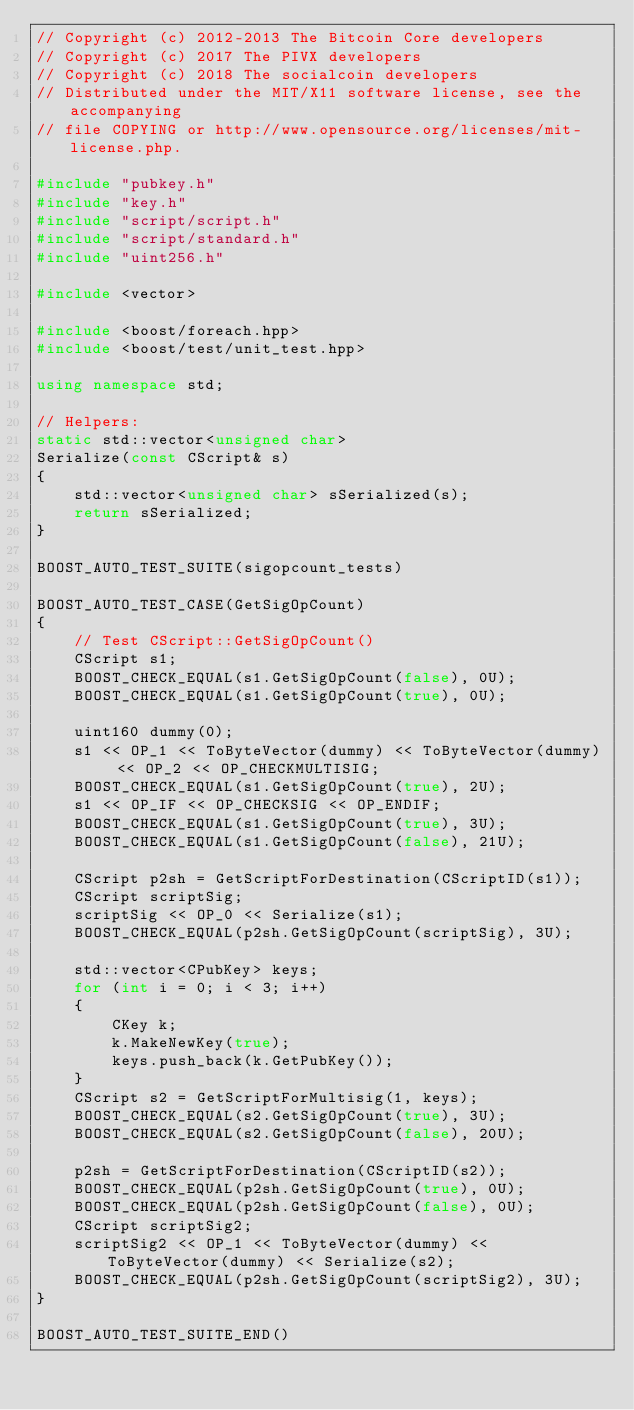Convert code to text. <code><loc_0><loc_0><loc_500><loc_500><_C++_>// Copyright (c) 2012-2013 The Bitcoin Core developers
// Copyright (c) 2017 The PIVX developers
// Copyright (c) 2018 The socialcoin developers
// Distributed under the MIT/X11 software license, see the accompanying
// file COPYING or http://www.opensource.org/licenses/mit-license.php.

#include "pubkey.h"
#include "key.h"
#include "script/script.h"
#include "script/standard.h"
#include "uint256.h"

#include <vector>

#include <boost/foreach.hpp>
#include <boost/test/unit_test.hpp>

using namespace std;

// Helpers:
static std::vector<unsigned char>
Serialize(const CScript& s)
{
    std::vector<unsigned char> sSerialized(s);
    return sSerialized;
}

BOOST_AUTO_TEST_SUITE(sigopcount_tests)

BOOST_AUTO_TEST_CASE(GetSigOpCount)
{
    // Test CScript::GetSigOpCount()
    CScript s1;
    BOOST_CHECK_EQUAL(s1.GetSigOpCount(false), 0U);
    BOOST_CHECK_EQUAL(s1.GetSigOpCount(true), 0U);

    uint160 dummy(0);
    s1 << OP_1 << ToByteVector(dummy) << ToByteVector(dummy) << OP_2 << OP_CHECKMULTISIG;
    BOOST_CHECK_EQUAL(s1.GetSigOpCount(true), 2U);
    s1 << OP_IF << OP_CHECKSIG << OP_ENDIF;
    BOOST_CHECK_EQUAL(s1.GetSigOpCount(true), 3U);
    BOOST_CHECK_EQUAL(s1.GetSigOpCount(false), 21U);

    CScript p2sh = GetScriptForDestination(CScriptID(s1));
    CScript scriptSig;
    scriptSig << OP_0 << Serialize(s1);
    BOOST_CHECK_EQUAL(p2sh.GetSigOpCount(scriptSig), 3U);

    std::vector<CPubKey> keys;
    for (int i = 0; i < 3; i++)
    {
        CKey k;
        k.MakeNewKey(true);
        keys.push_back(k.GetPubKey());
    }
    CScript s2 = GetScriptForMultisig(1, keys);
    BOOST_CHECK_EQUAL(s2.GetSigOpCount(true), 3U);
    BOOST_CHECK_EQUAL(s2.GetSigOpCount(false), 20U);

    p2sh = GetScriptForDestination(CScriptID(s2));
    BOOST_CHECK_EQUAL(p2sh.GetSigOpCount(true), 0U);
    BOOST_CHECK_EQUAL(p2sh.GetSigOpCount(false), 0U);
    CScript scriptSig2;
    scriptSig2 << OP_1 << ToByteVector(dummy) << ToByteVector(dummy) << Serialize(s2);
    BOOST_CHECK_EQUAL(p2sh.GetSigOpCount(scriptSig2), 3U);
}

BOOST_AUTO_TEST_SUITE_END()
</code> 